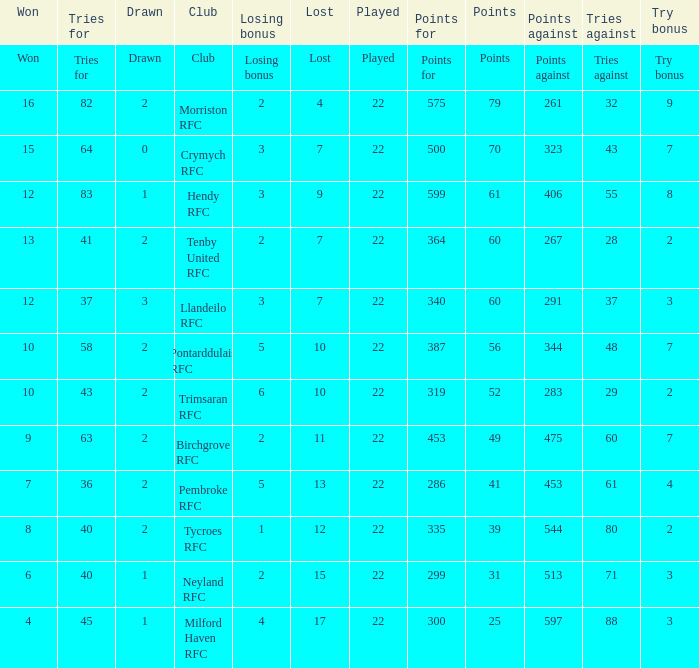 how many points against with tries for being 43 1.0. 